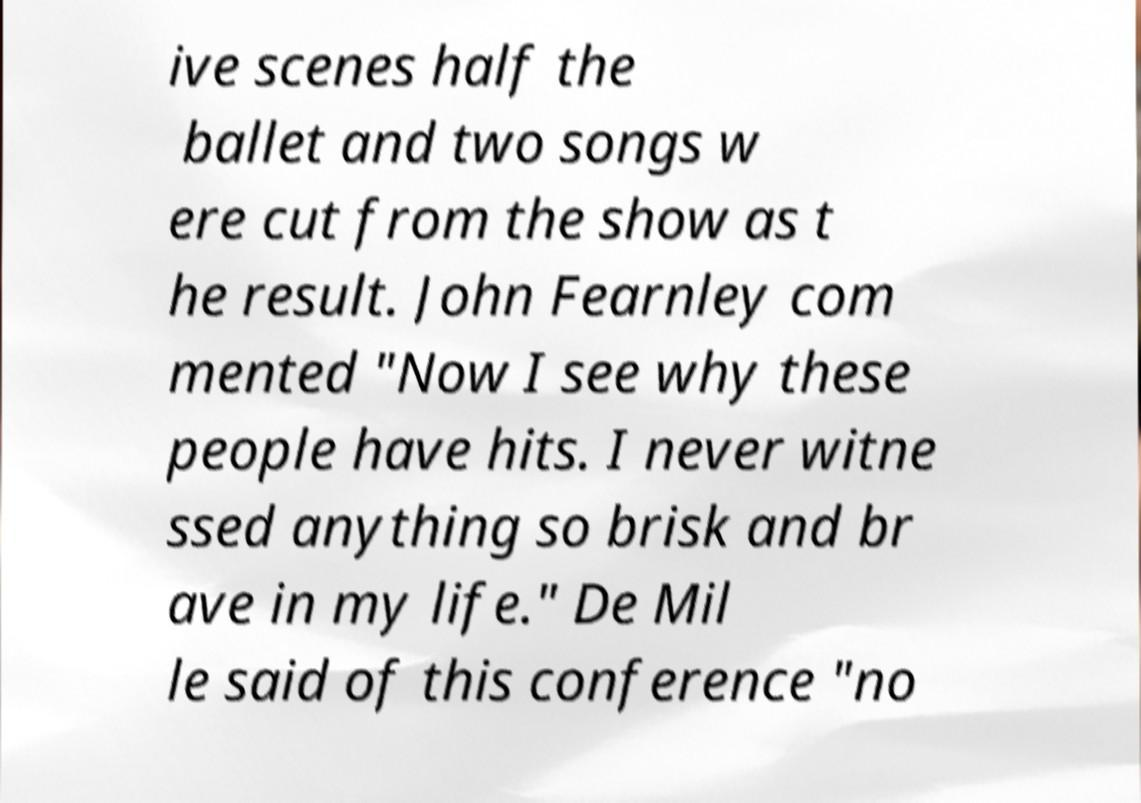There's text embedded in this image that I need extracted. Can you transcribe it verbatim? ive scenes half the ballet and two songs w ere cut from the show as t he result. John Fearnley com mented "Now I see why these people have hits. I never witne ssed anything so brisk and br ave in my life." De Mil le said of this conference "no 